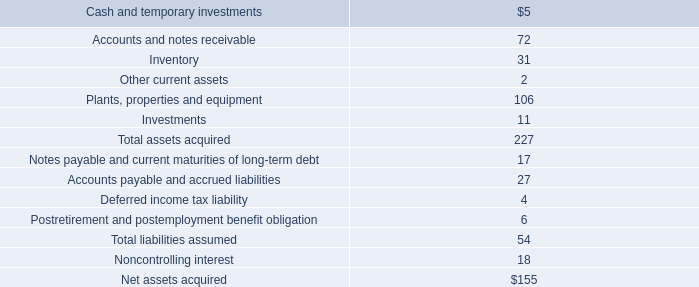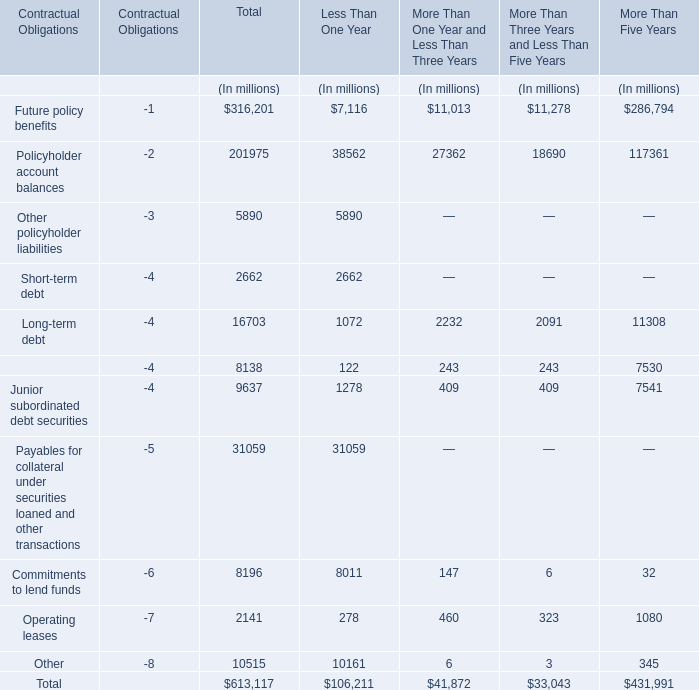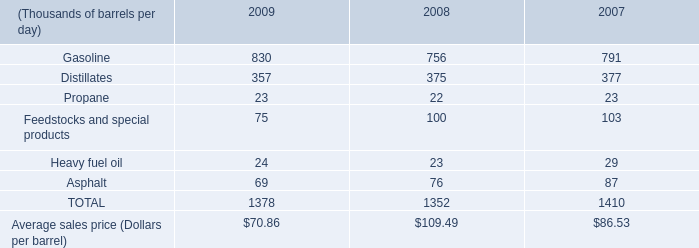what were total ethanol volumes sold in blended gasoline in 2009 , 2008 , and 2007 in tbd? 
Computations: ((60 + 54) + 40)
Answer: 154.0. 